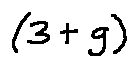Convert formula to latex. <formula><loc_0><loc_0><loc_500><loc_500>( 3 + g )</formula> 